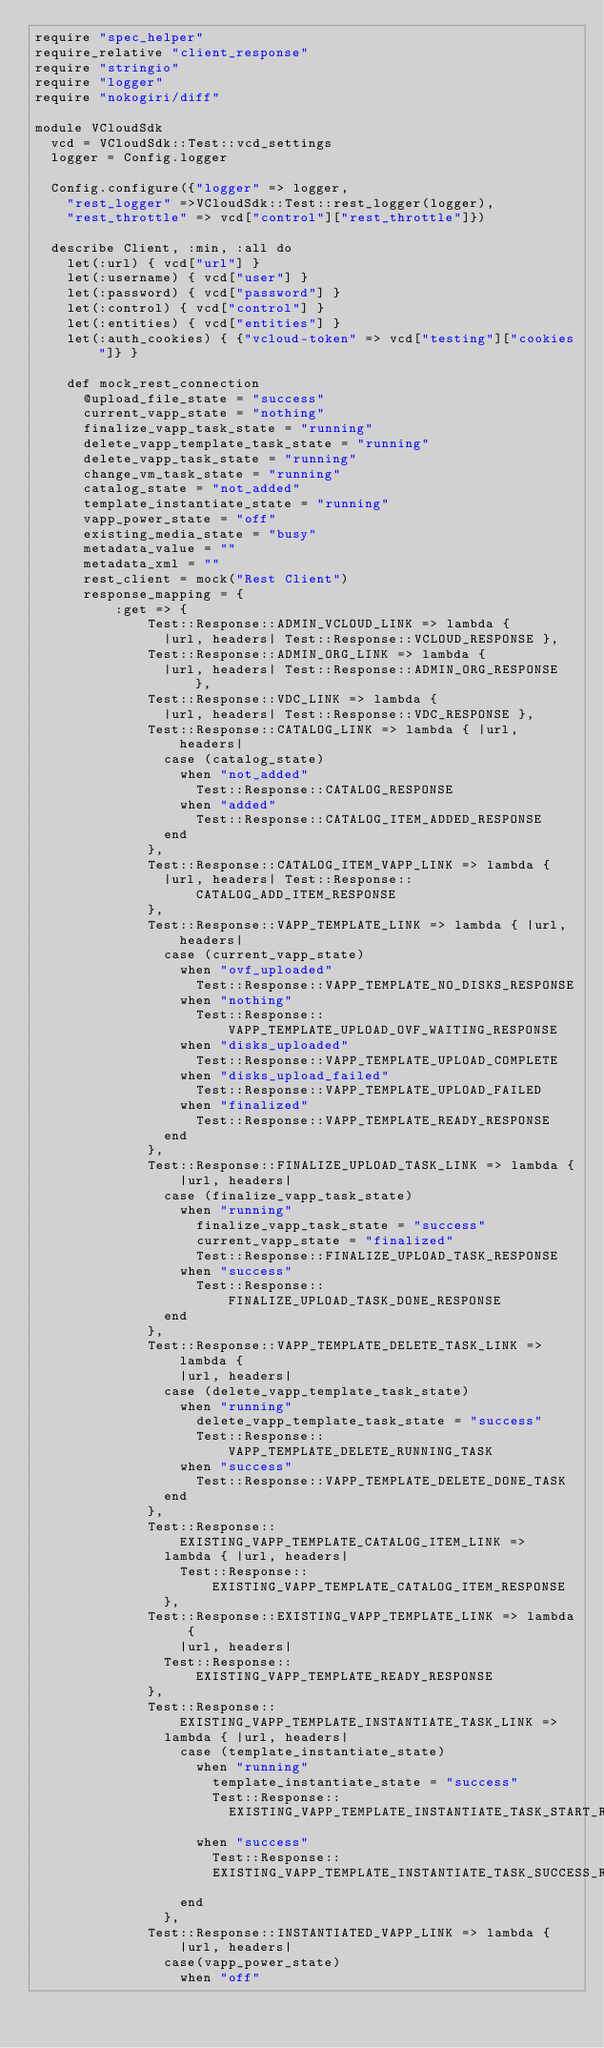<code> <loc_0><loc_0><loc_500><loc_500><_Ruby_>require "spec_helper"
require_relative "client_response"
require "stringio"
require "logger"
require "nokogiri/diff"

module VCloudSdk
  vcd = VCloudSdk::Test::vcd_settings
  logger = Config.logger

  Config.configure({"logger" => logger,
    "rest_logger" =>VCloudSdk::Test::rest_logger(logger),
    "rest_throttle" => vcd["control"]["rest_throttle"]})

  describe Client, :min, :all do
    let(:url) { vcd["url"] }
    let(:username) { vcd["user"] }
    let(:password) { vcd["password"] }
    let(:control) { vcd["control"] }
    let(:entities) { vcd["entities"] }
    let(:auth_cookies) { {"vcloud-token" => vcd["testing"]["cookies"]} }

    def mock_rest_connection
      @upload_file_state = "success"
      current_vapp_state = "nothing"
      finalize_vapp_task_state = "running"
      delete_vapp_template_task_state = "running"
      delete_vapp_task_state = "running"
      change_vm_task_state = "running"
      catalog_state = "not_added"
      template_instantiate_state = "running"
      vapp_power_state = "off"
      existing_media_state = "busy"
      metadata_value = ""
      metadata_xml = ""
      rest_client = mock("Rest Client")
      response_mapping = {
          :get => {
              Test::Response::ADMIN_VCLOUD_LINK => lambda {
                |url, headers| Test::Response::VCLOUD_RESPONSE },
              Test::Response::ADMIN_ORG_LINK => lambda {
                |url, headers| Test::Response::ADMIN_ORG_RESPONSE },
              Test::Response::VDC_LINK => lambda {
                |url, headers| Test::Response::VDC_RESPONSE },
              Test::Response::CATALOG_LINK => lambda { |url, headers|
                case (catalog_state)
                  when "not_added"
                    Test::Response::CATALOG_RESPONSE
                  when "added"
                    Test::Response::CATALOG_ITEM_ADDED_RESPONSE
                end
              },
              Test::Response::CATALOG_ITEM_VAPP_LINK => lambda {
                |url, headers| Test::Response::CATALOG_ADD_ITEM_RESPONSE
              },
              Test::Response::VAPP_TEMPLATE_LINK => lambda { |url, headers|
                case (current_vapp_state)
                  when "ovf_uploaded"
                    Test::Response::VAPP_TEMPLATE_NO_DISKS_RESPONSE
                  when "nothing"
                    Test::Response::VAPP_TEMPLATE_UPLOAD_OVF_WAITING_RESPONSE
                  when "disks_uploaded"
                    Test::Response::VAPP_TEMPLATE_UPLOAD_COMPLETE
                  when "disks_upload_failed"
                    Test::Response::VAPP_TEMPLATE_UPLOAD_FAILED
                  when "finalized"
                    Test::Response::VAPP_TEMPLATE_READY_RESPONSE
                end
              },
              Test::Response::FINALIZE_UPLOAD_TASK_LINK => lambda {
                  |url, headers|
                case (finalize_vapp_task_state)
                  when "running"
                    finalize_vapp_task_state = "success"
                    current_vapp_state = "finalized"
                    Test::Response::FINALIZE_UPLOAD_TASK_RESPONSE
                  when "success"
                    Test::Response::FINALIZE_UPLOAD_TASK_DONE_RESPONSE
                end
              },
              Test::Response::VAPP_TEMPLATE_DELETE_TASK_LINK => lambda {
                  |url, headers|
                case (delete_vapp_template_task_state)
                  when "running"
                    delete_vapp_template_task_state = "success"
                    Test::Response::VAPP_TEMPLATE_DELETE_RUNNING_TASK
                  when "success"
                    Test::Response::VAPP_TEMPLATE_DELETE_DONE_TASK
                end
              },
              Test::Response::EXISTING_VAPP_TEMPLATE_CATALOG_ITEM_LINK =>
                lambda { |url, headers|
                  Test::Response::EXISTING_VAPP_TEMPLATE_CATALOG_ITEM_RESPONSE
                },
              Test::Response::EXISTING_VAPP_TEMPLATE_LINK => lambda {
                  |url, headers|
                Test::Response::EXISTING_VAPP_TEMPLATE_READY_RESPONSE
              },
              Test::Response::EXISTING_VAPP_TEMPLATE_INSTANTIATE_TASK_LINK =>
                lambda { |url, headers|
                  case (template_instantiate_state)
                    when "running"
                      template_instantiate_state = "success"
                      Test::Response::
                        EXISTING_VAPP_TEMPLATE_INSTANTIATE_TASK_START_RESPONSE
                    when "success"
                      Test::Response::
                      EXISTING_VAPP_TEMPLATE_INSTANTIATE_TASK_SUCCESS_RESPONSE
                  end
                },
              Test::Response::INSTANTIATED_VAPP_LINK => lambda {
                  |url, headers|
                case(vapp_power_state)
                  when "off"</code> 